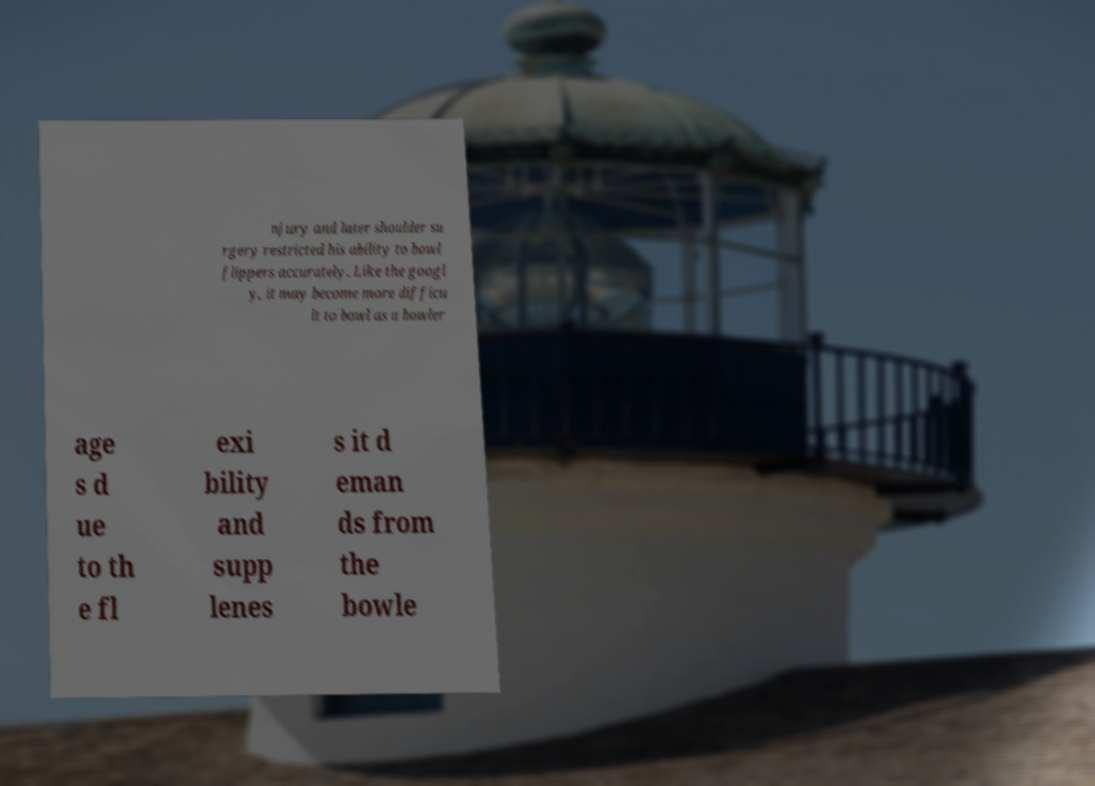Could you extract and type out the text from this image? njury and later shoulder su rgery restricted his ability to bowl flippers accurately. Like the googl y, it may become more difficu lt to bowl as a bowler age s d ue to th e fl exi bility and supp lenes s it d eman ds from the bowle 